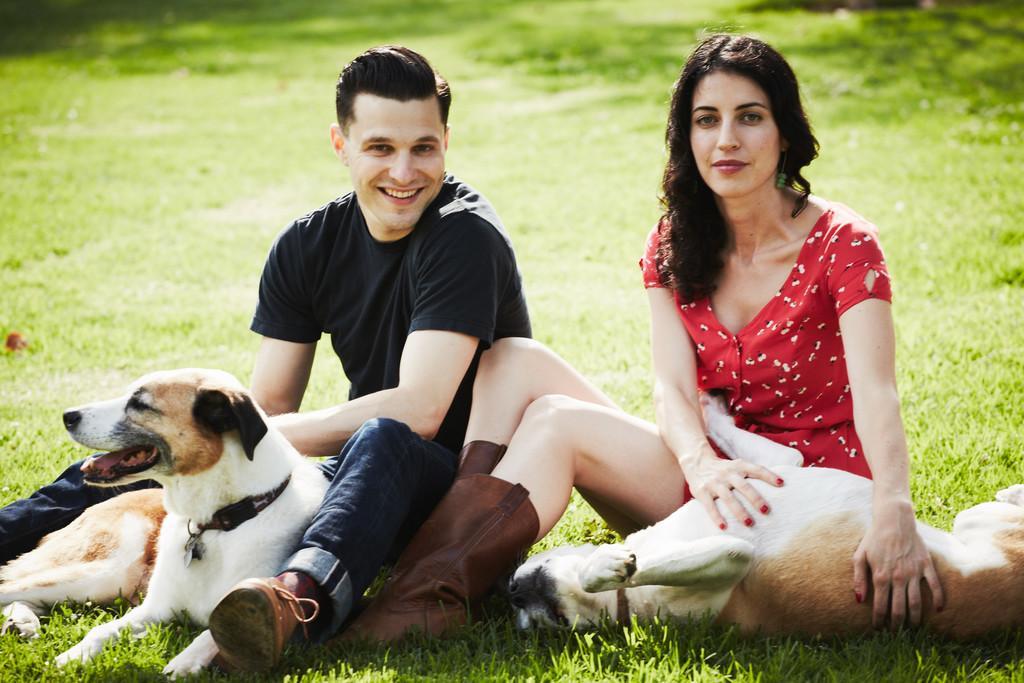Can you describe this image briefly? These two persons are sitting and smiling and holding dogs. This is grass. 